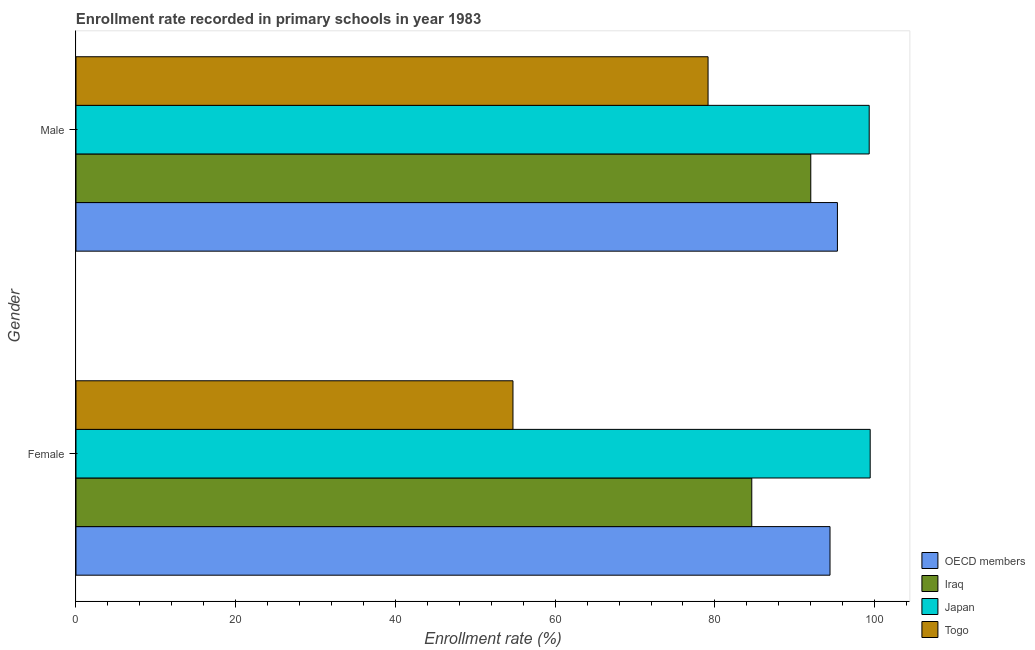How many different coloured bars are there?
Make the answer very short. 4. Are the number of bars on each tick of the Y-axis equal?
Offer a terse response. Yes. How many bars are there on the 2nd tick from the top?
Make the answer very short. 4. How many bars are there on the 1st tick from the bottom?
Offer a very short reply. 4. What is the enrollment rate of male students in Iraq?
Provide a succinct answer. 92. Across all countries, what is the maximum enrollment rate of male students?
Keep it short and to the point. 99.32. Across all countries, what is the minimum enrollment rate of female students?
Your response must be concise. 54.71. In which country was the enrollment rate of female students maximum?
Keep it short and to the point. Japan. In which country was the enrollment rate of male students minimum?
Make the answer very short. Togo. What is the total enrollment rate of female students in the graph?
Ensure brevity in your answer.  333.18. What is the difference between the enrollment rate of female students in Iraq and that in OECD members?
Your answer should be very brief. -9.8. What is the difference between the enrollment rate of male students in Japan and the enrollment rate of female students in Iraq?
Your answer should be very brief. 14.7. What is the average enrollment rate of male students per country?
Offer a terse response. 91.45. What is the difference between the enrollment rate of female students and enrollment rate of male students in Japan?
Offer a very short reply. 0.12. In how many countries, is the enrollment rate of female students greater than 64 %?
Ensure brevity in your answer.  3. What is the ratio of the enrollment rate of female students in Iraq to that in OECD members?
Offer a terse response. 0.9. What does the 4th bar from the top in Male represents?
Keep it short and to the point. OECD members. What does the 2nd bar from the bottom in Male represents?
Give a very brief answer. Iraq. How many countries are there in the graph?
Provide a succinct answer. 4. What is the difference between two consecutive major ticks on the X-axis?
Provide a short and direct response. 20. Are the values on the major ticks of X-axis written in scientific E-notation?
Offer a terse response. No. Does the graph contain any zero values?
Your response must be concise. No. Where does the legend appear in the graph?
Give a very brief answer. Bottom right. How are the legend labels stacked?
Make the answer very short. Vertical. What is the title of the graph?
Your response must be concise. Enrollment rate recorded in primary schools in year 1983. Does "Somalia" appear as one of the legend labels in the graph?
Ensure brevity in your answer.  No. What is the label or title of the X-axis?
Your answer should be very brief. Enrollment rate (%). What is the label or title of the Y-axis?
Make the answer very short. Gender. What is the Enrollment rate (%) of OECD members in Female?
Offer a terse response. 94.41. What is the Enrollment rate (%) in Iraq in Female?
Provide a short and direct response. 84.61. What is the Enrollment rate (%) in Japan in Female?
Make the answer very short. 99.44. What is the Enrollment rate (%) in Togo in Female?
Provide a succinct answer. 54.71. What is the Enrollment rate (%) in OECD members in Male?
Your answer should be compact. 95.34. What is the Enrollment rate (%) in Iraq in Male?
Keep it short and to the point. 92. What is the Enrollment rate (%) in Japan in Male?
Ensure brevity in your answer.  99.32. What is the Enrollment rate (%) of Togo in Male?
Offer a terse response. 79.14. Across all Gender, what is the maximum Enrollment rate (%) of OECD members?
Your answer should be very brief. 95.34. Across all Gender, what is the maximum Enrollment rate (%) in Iraq?
Keep it short and to the point. 92. Across all Gender, what is the maximum Enrollment rate (%) in Japan?
Provide a short and direct response. 99.44. Across all Gender, what is the maximum Enrollment rate (%) in Togo?
Your answer should be very brief. 79.14. Across all Gender, what is the minimum Enrollment rate (%) in OECD members?
Offer a terse response. 94.41. Across all Gender, what is the minimum Enrollment rate (%) in Iraq?
Your answer should be very brief. 84.61. Across all Gender, what is the minimum Enrollment rate (%) in Japan?
Provide a short and direct response. 99.32. Across all Gender, what is the minimum Enrollment rate (%) in Togo?
Your answer should be compact. 54.71. What is the total Enrollment rate (%) in OECD members in the graph?
Make the answer very short. 189.75. What is the total Enrollment rate (%) of Iraq in the graph?
Your answer should be very brief. 176.62. What is the total Enrollment rate (%) of Japan in the graph?
Keep it short and to the point. 198.76. What is the total Enrollment rate (%) of Togo in the graph?
Your response must be concise. 133.85. What is the difference between the Enrollment rate (%) in OECD members in Female and that in Male?
Keep it short and to the point. -0.93. What is the difference between the Enrollment rate (%) of Iraq in Female and that in Male?
Offer a very short reply. -7.39. What is the difference between the Enrollment rate (%) of Japan in Female and that in Male?
Ensure brevity in your answer.  0.12. What is the difference between the Enrollment rate (%) of Togo in Female and that in Male?
Your answer should be very brief. -24.43. What is the difference between the Enrollment rate (%) in OECD members in Female and the Enrollment rate (%) in Iraq in Male?
Keep it short and to the point. 2.41. What is the difference between the Enrollment rate (%) in OECD members in Female and the Enrollment rate (%) in Japan in Male?
Your response must be concise. -4.91. What is the difference between the Enrollment rate (%) in OECD members in Female and the Enrollment rate (%) in Togo in Male?
Offer a terse response. 15.27. What is the difference between the Enrollment rate (%) of Iraq in Female and the Enrollment rate (%) of Japan in Male?
Offer a very short reply. -14.7. What is the difference between the Enrollment rate (%) of Iraq in Female and the Enrollment rate (%) of Togo in Male?
Offer a very short reply. 5.47. What is the difference between the Enrollment rate (%) in Japan in Female and the Enrollment rate (%) in Togo in Male?
Give a very brief answer. 20.3. What is the average Enrollment rate (%) of OECD members per Gender?
Provide a short and direct response. 94.87. What is the average Enrollment rate (%) in Iraq per Gender?
Your answer should be very brief. 88.31. What is the average Enrollment rate (%) of Japan per Gender?
Offer a terse response. 99.38. What is the average Enrollment rate (%) of Togo per Gender?
Your answer should be compact. 66.93. What is the difference between the Enrollment rate (%) in OECD members and Enrollment rate (%) in Iraq in Female?
Provide a short and direct response. 9.8. What is the difference between the Enrollment rate (%) in OECD members and Enrollment rate (%) in Japan in Female?
Give a very brief answer. -5.03. What is the difference between the Enrollment rate (%) in OECD members and Enrollment rate (%) in Togo in Female?
Offer a very short reply. 39.7. What is the difference between the Enrollment rate (%) of Iraq and Enrollment rate (%) of Japan in Female?
Offer a terse response. -14.83. What is the difference between the Enrollment rate (%) in Iraq and Enrollment rate (%) in Togo in Female?
Your answer should be compact. 29.9. What is the difference between the Enrollment rate (%) in Japan and Enrollment rate (%) in Togo in Female?
Give a very brief answer. 44.73. What is the difference between the Enrollment rate (%) in OECD members and Enrollment rate (%) in Iraq in Male?
Provide a short and direct response. 3.34. What is the difference between the Enrollment rate (%) of OECD members and Enrollment rate (%) of Japan in Male?
Provide a short and direct response. -3.98. What is the difference between the Enrollment rate (%) of OECD members and Enrollment rate (%) of Togo in Male?
Provide a succinct answer. 16.2. What is the difference between the Enrollment rate (%) in Iraq and Enrollment rate (%) in Japan in Male?
Your answer should be very brief. -7.32. What is the difference between the Enrollment rate (%) in Iraq and Enrollment rate (%) in Togo in Male?
Your answer should be very brief. 12.86. What is the difference between the Enrollment rate (%) of Japan and Enrollment rate (%) of Togo in Male?
Offer a terse response. 20.18. What is the ratio of the Enrollment rate (%) in OECD members in Female to that in Male?
Offer a terse response. 0.99. What is the ratio of the Enrollment rate (%) in Iraq in Female to that in Male?
Keep it short and to the point. 0.92. What is the ratio of the Enrollment rate (%) of Togo in Female to that in Male?
Make the answer very short. 0.69. What is the difference between the highest and the second highest Enrollment rate (%) of OECD members?
Your answer should be compact. 0.93. What is the difference between the highest and the second highest Enrollment rate (%) of Iraq?
Provide a short and direct response. 7.39. What is the difference between the highest and the second highest Enrollment rate (%) in Japan?
Make the answer very short. 0.12. What is the difference between the highest and the second highest Enrollment rate (%) in Togo?
Provide a succinct answer. 24.43. What is the difference between the highest and the lowest Enrollment rate (%) in OECD members?
Provide a succinct answer. 0.93. What is the difference between the highest and the lowest Enrollment rate (%) in Iraq?
Ensure brevity in your answer.  7.39. What is the difference between the highest and the lowest Enrollment rate (%) in Japan?
Your answer should be compact. 0.12. What is the difference between the highest and the lowest Enrollment rate (%) of Togo?
Give a very brief answer. 24.43. 